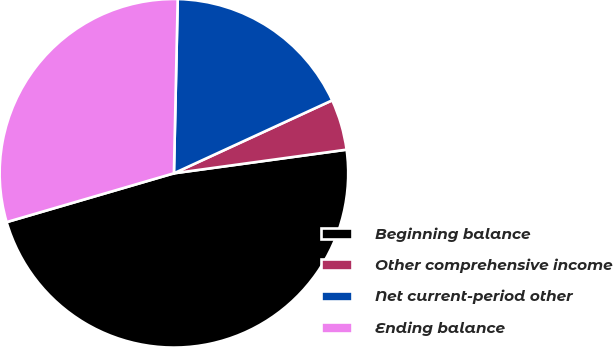Convert chart to OTSL. <chart><loc_0><loc_0><loc_500><loc_500><pie_chart><fcel>Beginning balance<fcel>Other comprehensive income<fcel>Net current-period other<fcel>Ending balance<nl><fcel>47.65%<fcel>4.71%<fcel>17.78%<fcel>29.87%<nl></chart> 